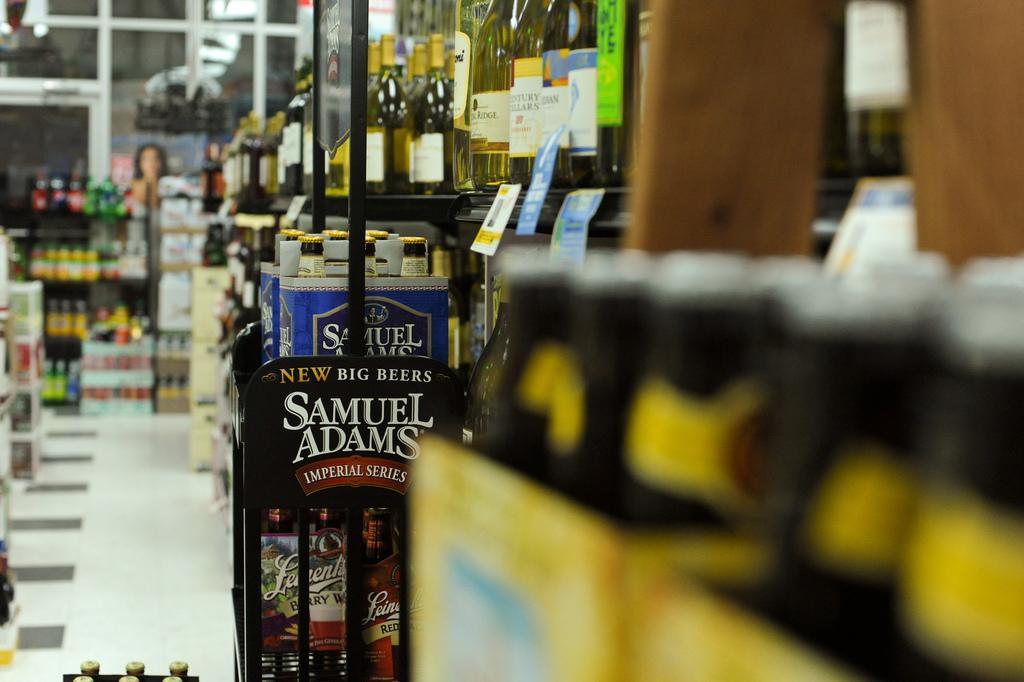Please provide a concise description of this image. In this picture we can see the inside view of a store. Here we can see some bottles in the rack. And this is the floor. 